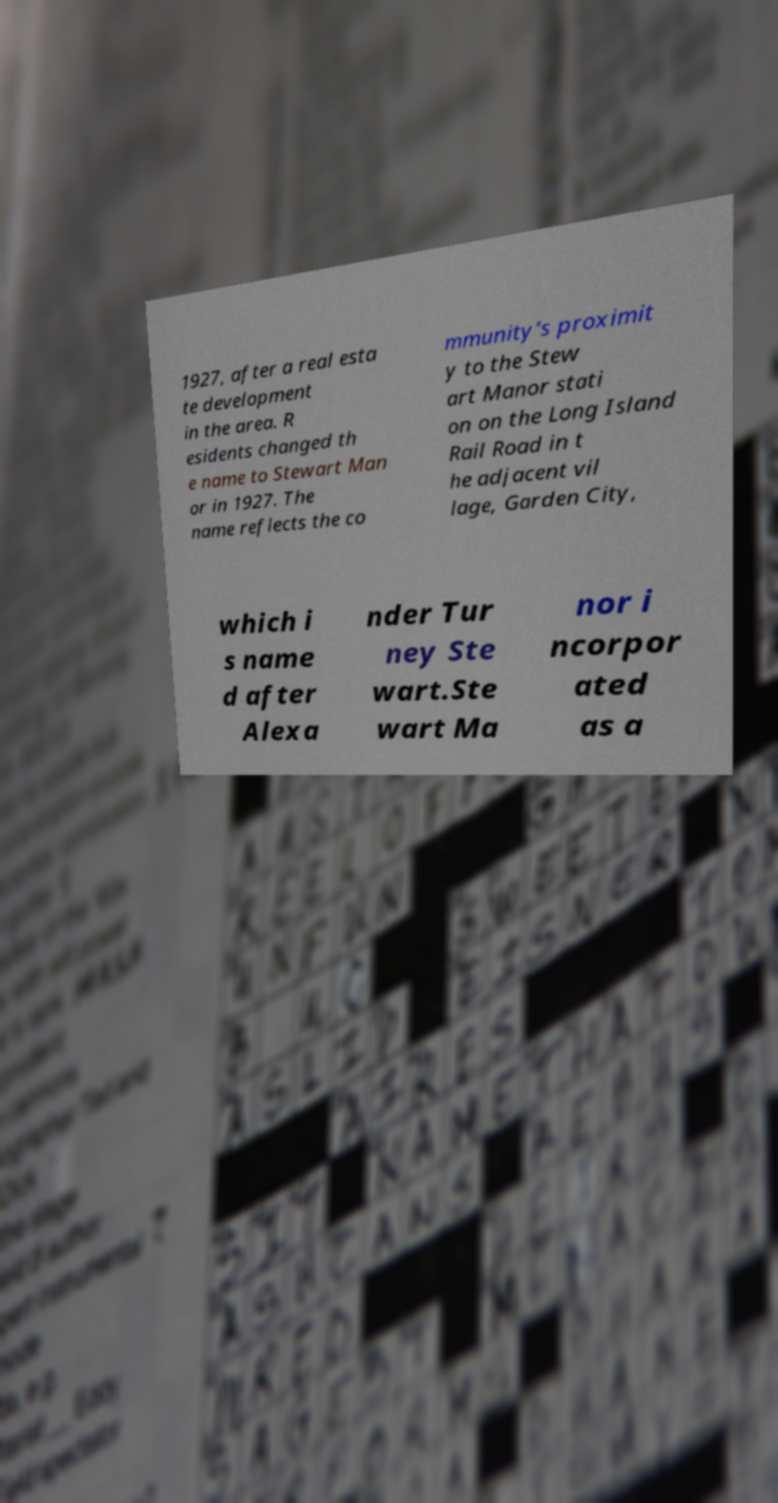For documentation purposes, I need the text within this image transcribed. Could you provide that? 1927, after a real esta te development in the area. R esidents changed th e name to Stewart Man or in 1927. The name reflects the co mmunity's proximit y to the Stew art Manor stati on on the Long Island Rail Road in t he adjacent vil lage, Garden City, which i s name d after Alexa nder Tur ney Ste wart.Ste wart Ma nor i ncorpor ated as a 